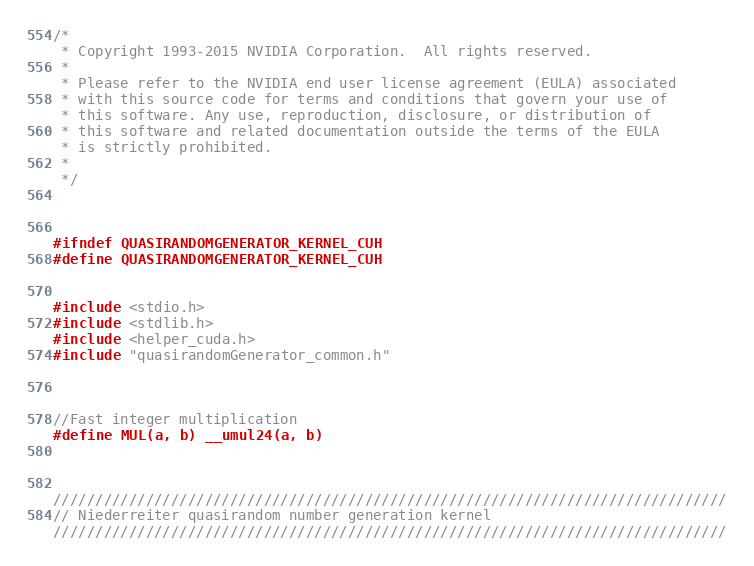<code> <loc_0><loc_0><loc_500><loc_500><_Cuda_>/*
 * Copyright 1993-2015 NVIDIA Corporation.  All rights reserved.
 *
 * Please refer to the NVIDIA end user license agreement (EULA) associated
 * with this source code for terms and conditions that govern your use of
 * this software. Any use, reproduction, disclosure, or distribution of
 * this software and related documentation outside the terms of the EULA
 * is strictly prohibited.
 *
 */



#ifndef QUASIRANDOMGENERATOR_KERNEL_CUH
#define QUASIRANDOMGENERATOR_KERNEL_CUH


#include <stdio.h>
#include <stdlib.h>
#include <helper_cuda.h>
#include "quasirandomGenerator_common.h"



//Fast integer multiplication
#define MUL(a, b) __umul24(a, b)



////////////////////////////////////////////////////////////////////////////////
// Niederreiter quasirandom number generation kernel
////////////////////////////////////////////////////////////////////////////////</code> 